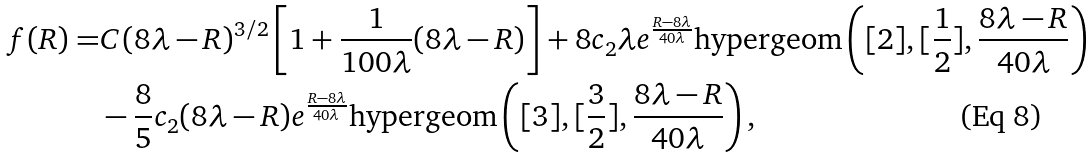<formula> <loc_0><loc_0><loc_500><loc_500>f ( R ) = & C ( 8 \lambda - R ) ^ { 3 / 2 } \left [ 1 + \frac { 1 } { 1 0 0 \lambda } ( 8 \lambda - R ) \right ] + 8 c _ { 2 } \lambda e ^ { \frac { R - 8 \lambda } { 4 0 \lambda } } \text {hypergeom} \left ( [ 2 ] , [ \frac { 1 } { 2 } ] , \frac { 8 \lambda - R } { 4 0 \lambda } \right ) \\ & - \frac { 8 } { 5 } c _ { 2 } ( 8 \lambda - R ) e ^ { \frac { R - 8 \lambda } { 4 0 \lambda } } \text {hypergeom} \left ( [ 3 ] , [ \frac { 3 } { 2 } ] , \frac { 8 \lambda - R } { 4 0 \lambda } \right ) ,</formula> 